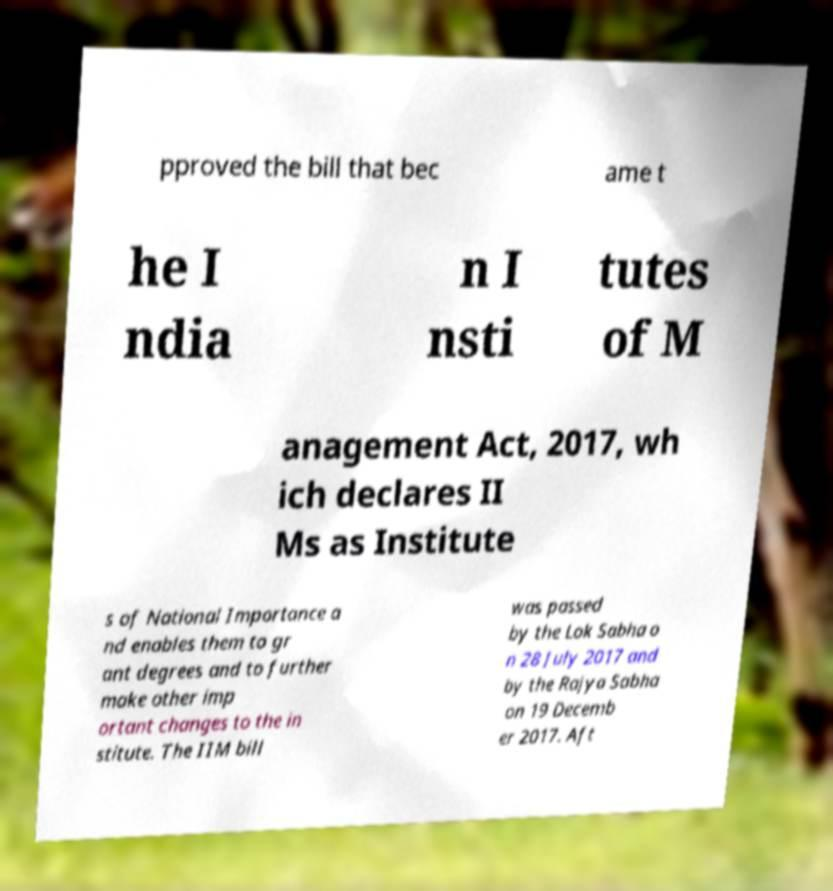Can you accurately transcribe the text from the provided image for me? pproved the bill that bec ame t he I ndia n I nsti tutes of M anagement Act, 2017, wh ich declares II Ms as Institute s of National Importance a nd enables them to gr ant degrees and to further make other imp ortant changes to the in stitute. The IIM bill was passed by the Lok Sabha o n 28 July 2017 and by the Rajya Sabha on 19 Decemb er 2017. Aft 